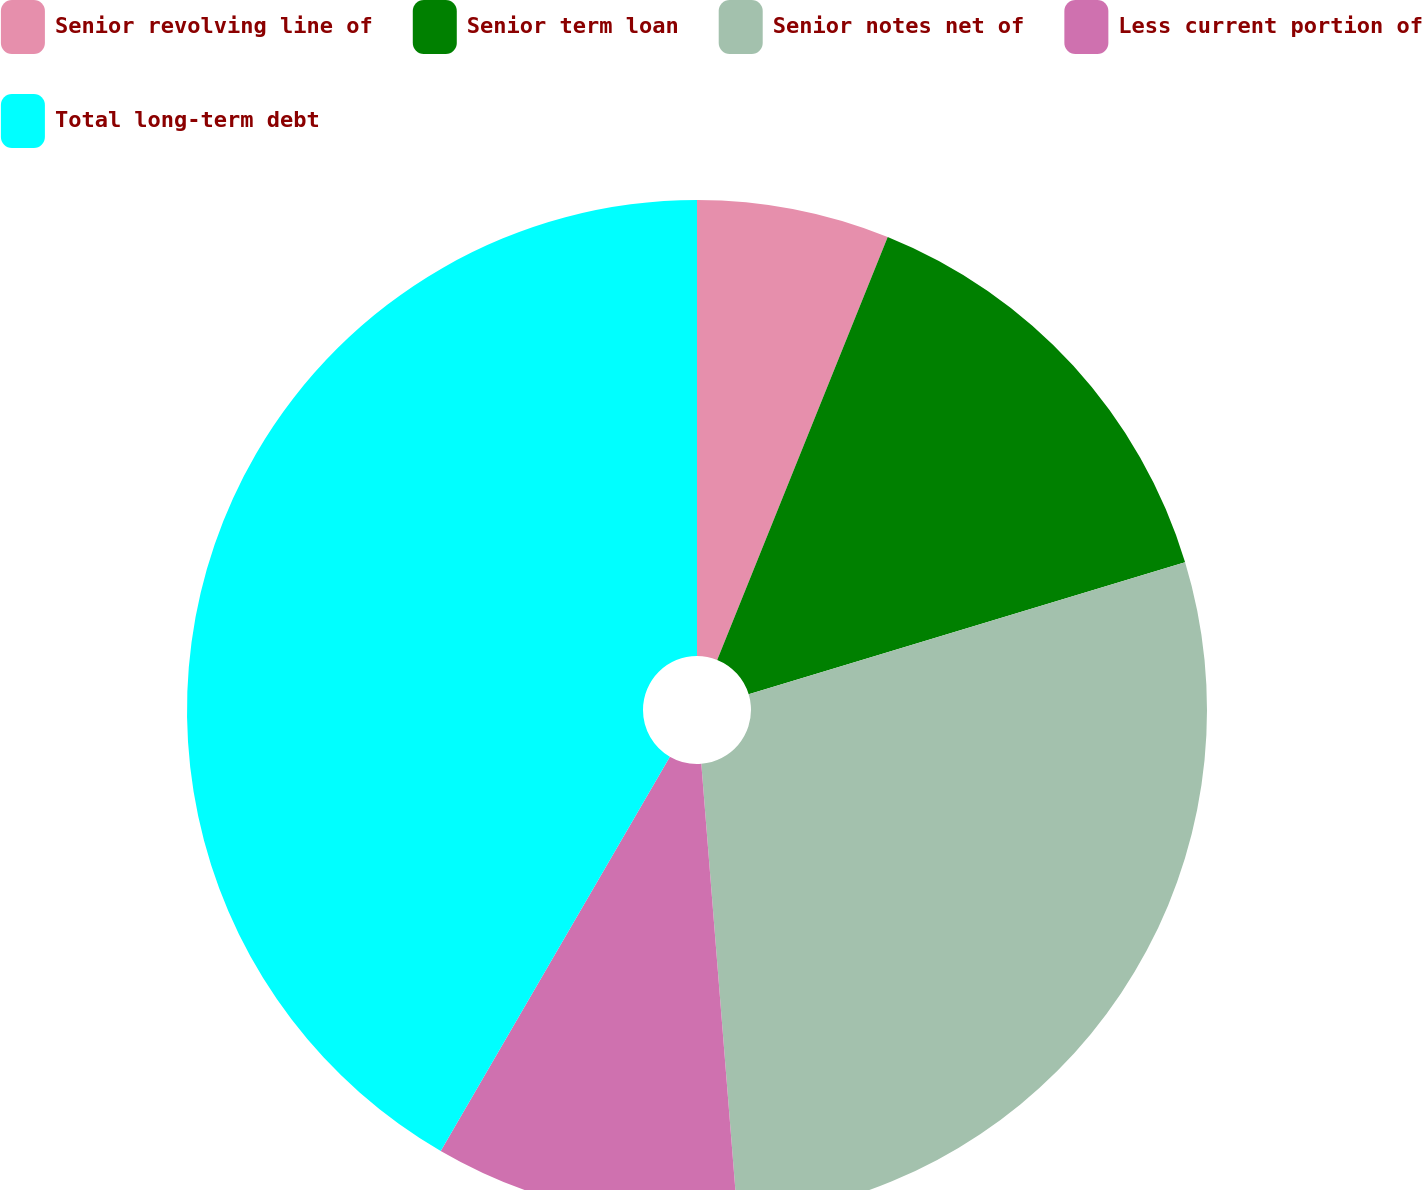<chart> <loc_0><loc_0><loc_500><loc_500><pie_chart><fcel>Senior revolving line of<fcel>Senior term loan<fcel>Senior notes net of<fcel>Less current portion of<fcel>Total long-term debt<nl><fcel>6.1%<fcel>14.22%<fcel>28.41%<fcel>9.65%<fcel>41.62%<nl></chart> 